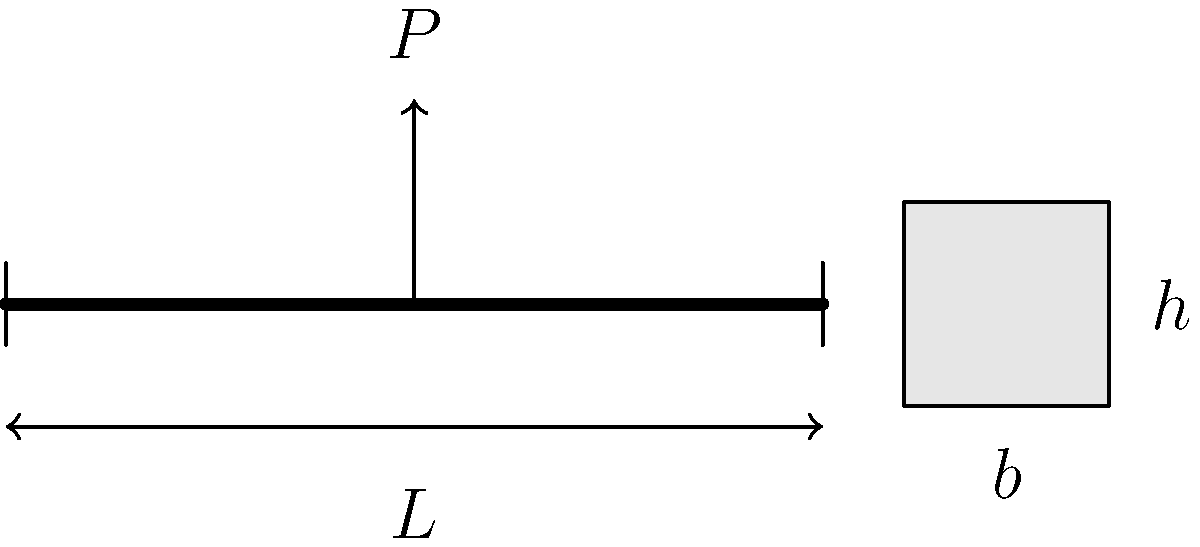As a satisfied client who has worked with this designer before, you're now facing a structural engineering challenge. A simply supported rectangular beam of length $L = 6$ m is subjected to a point load $P = 50$ kN at its midspan. The allowable bending stress of the material is $\sigma_{allow} = 12$ MPa, and the width-to-depth ratio of the beam is fixed at 1:2. Calculate the required width $(b)$ and depth $(h)$ of the beam to the nearest centimeter. Let's approach this step-by-step:

1) The maximum bending moment $(M_{max})$ occurs at the midspan:
   $$M_{max} = \frac{PL}{4} = \frac{50 \times 6}{4} = 75 \text{ kN·m} = 75 \times 10^6 \text{ N·mm}$$

2) The section modulus $(S)$ is related to the allowable stress and maximum moment:
   $$S = \frac{M_{max}}{\sigma_{allow}} = \frac{75 \times 10^6}{12} = 6.25 \times 10^6 \text{ mm}^3$$

3) For a rectangular section, $S = \frac{bh^2}{6}$. Given that $h = 2b$:
   $$6.25 \times 10^6 = \frac{b(2b)^2}{6} = \frac{4b^3}{6}$$

4) Solving for $b$:
   $$b^3 = \frac{6.25 \times 10^6 \times 6}{4} = 9.375 \times 10^6$$
   $$b = \sqrt[3]{9.375 \times 10^6} = 210.8 \text{ mm}$$

5) Rounding to the nearest centimeter:
   $b = 21 \text{ cm}$
   $h = 2b = 42 \text{ cm}$
Answer: $b = 21 \text{ cm}, h = 42 \text{ cm}$ 